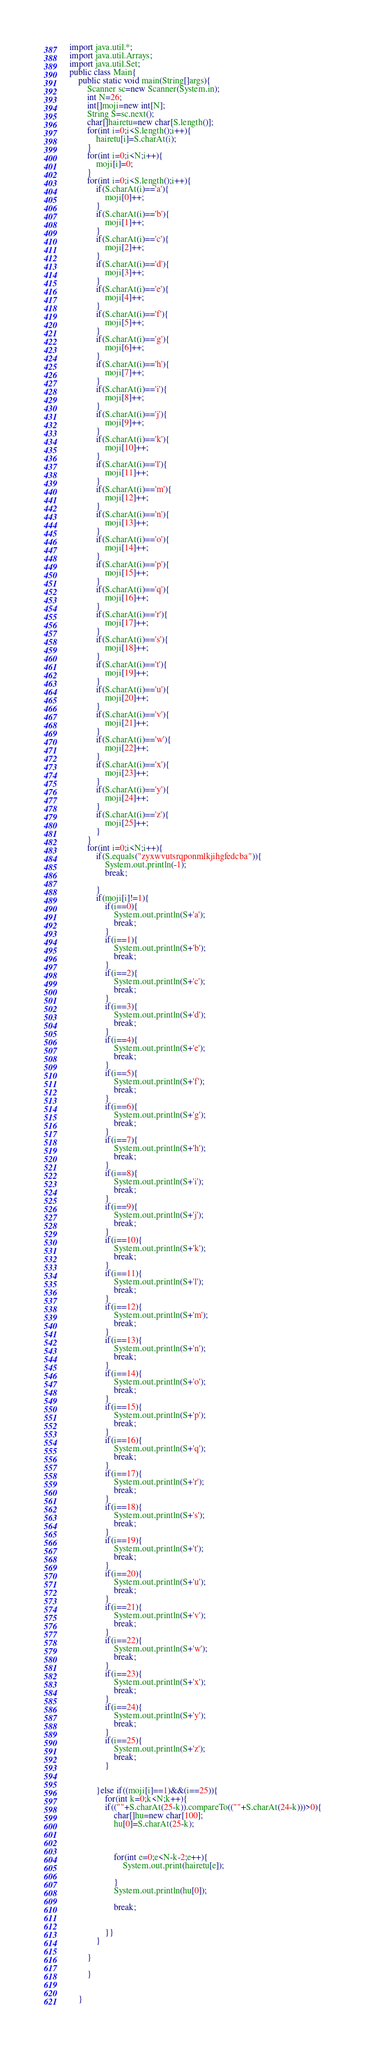Convert code to text. <code><loc_0><loc_0><loc_500><loc_500><_Java_>import java.util.*;
import java.util.Arrays;
import java.util.Set;
public class Main{
    public static void main(String[]args){
        Scanner sc=new Scanner(System.in);
        int N=26;
        int[]moji=new int[N];
        String S=sc.next();
        char[]hairetu=new char[S.length()];
        for(int i=0;i<S.length();i++){
            hairetu[i]=S.charAt(i);
        }
        for(int i=0;i<N;i++){
            moji[i]=0;
        }
        for(int i=0;i<S.length();i++){
			if(S.charAt(i)=='a'){
                moji[0]++;
            }
            if(S.charAt(i)=='b'){
                moji[1]++;
            }
            if(S.charAt(i)=='c'){
                moji[2]++;
            }
            if(S.charAt(i)=='d'){
                moji[3]++;
            }
            if(S.charAt(i)=='e'){
                moji[4]++;
            }
            if(S.charAt(i)=='f'){
                moji[5]++;
            }
            if(S.charAt(i)=='g'){
                moji[6]++;
            }
            if(S.charAt(i)=='h'){
                moji[7]++;
            }
            if(S.charAt(i)=='i'){
                moji[8]++;
            }
            if(S.charAt(i)=='j'){
                moji[9]++;
            }
            if(S.charAt(i)=='k'){
                moji[10]++;
            }
            if(S.charAt(i)=='l'){
                moji[11]++;
            }
            if(S.charAt(i)=='m'){
                moji[12]++;
            }
            if(S.charAt(i)=='n'){
                moji[13]++;
            }
            if(S.charAt(i)=='o'){
                moji[14]++;
            }
            if(S.charAt(i)=='p'){
                moji[15]++;
            }
            if(S.charAt(i)=='q'){
                moji[16]++;
            }
            if(S.charAt(i)=='r'){
                moji[17]++;
            }
            if(S.charAt(i)=='s'){
                moji[18]++;
            }
            if(S.charAt(i)=='t'){
                moji[19]++;
            }
            if(S.charAt(i)=='u'){
                moji[20]++;
            }
            if(S.charAt(i)=='v'){
                moji[21]++;
            }
            if(S.charAt(i)=='w'){
                moji[22]++;
            }
            if(S.charAt(i)=='x'){
                moji[23]++;
            }
            if(S.charAt(i)=='y'){
                moji[24]++;
            }
            if(S.charAt(i)=='z'){
                moji[25]++;
            }
        }
        for(int i=0;i<N;i++){
            if(S.equals("zyxwvutsrqponmlkjihgfedcba")){
                System.out.println(-1);
                break;

            }
            if(moji[i]!=1){
                if(i==0){
                    System.out.println(S+'a');
                    break;
                }
                if(i==1){
                    System.out.println(S+'b');
                    break;
                }
                if(i==2){
                    System.out.println(S+'c');
                    break;
                }
                if(i==3){
                    System.out.println(S+'d');
                    break;
                }
                if(i==4){
                    System.out.println(S+'e');
                    break;
                }
                if(i==5){
                    System.out.println(S+'f');
                    break;
                }
                if(i==6){
                    System.out.println(S+'g');
                    break;
                }
                if(i==7){
                    System.out.println(S+'h');
                    break;
                }
                if(i==8){
                    System.out.println(S+'i');
                    break;
                }
                if(i==9){
                    System.out.println(S+'j');
                    break;
                }
                if(i==10){
                    System.out.println(S+'k');
                    break;
                }
                if(i==11){
                    System.out.println(S+'l');
                    break;
                }
                if(i==12){
                    System.out.println(S+'m');
                    break;
                }
                if(i==13){
                    System.out.println(S+'n');
                    break;
                }
                if(i==14){
                    System.out.println(S+'o');
                    break;
                }
                if(i==15){
                    System.out.println(S+'p');
                    break;
                }
                if(i==16){
                    System.out.println(S+'q');
                    break;
                }
                if(i==17){
                    System.out.println(S+'r');
                    break;
                }
                if(i==18){
                    System.out.println(S+'s');
                    break;
                }
                if(i==19){
                    System.out.println(S+'t');
                    break;
                }
                if(i==20){
                    System.out.println(S+'u');
                    break;
                }
                if(i==21){
                    System.out.println(S+'v');
                    break;
                }
                if(i==22){
                    System.out.println(S+'w');
                    break;
                }
                if(i==23){
                    System.out.println(S+'x');
                    break;
                }
                if(i==24){
                    System.out.println(S+'y');
                    break;
                }
                if(i==25){
                    System.out.println(S+'z');
                    break;
                }
                

            }else if((moji[i]==1)&&(i==25)){
                for(int k=0;k<N;k++){
                if((""+S.charAt(25-k)).compareTo((""+S.charAt(24-k)))>0){
                    char[]hu=new char[100];
                    hu[0]=S.charAt(25-k);
                    
                    
                    
                    for(int e=0;e<N-k-2;e++){
                        System.out.print(hairetu[e]);
                        
                    }
                    System.out.println(hu[0]);
                    
                    break;
                   

                }}
            }
            
        }
        
        }
       
        
    }</code> 